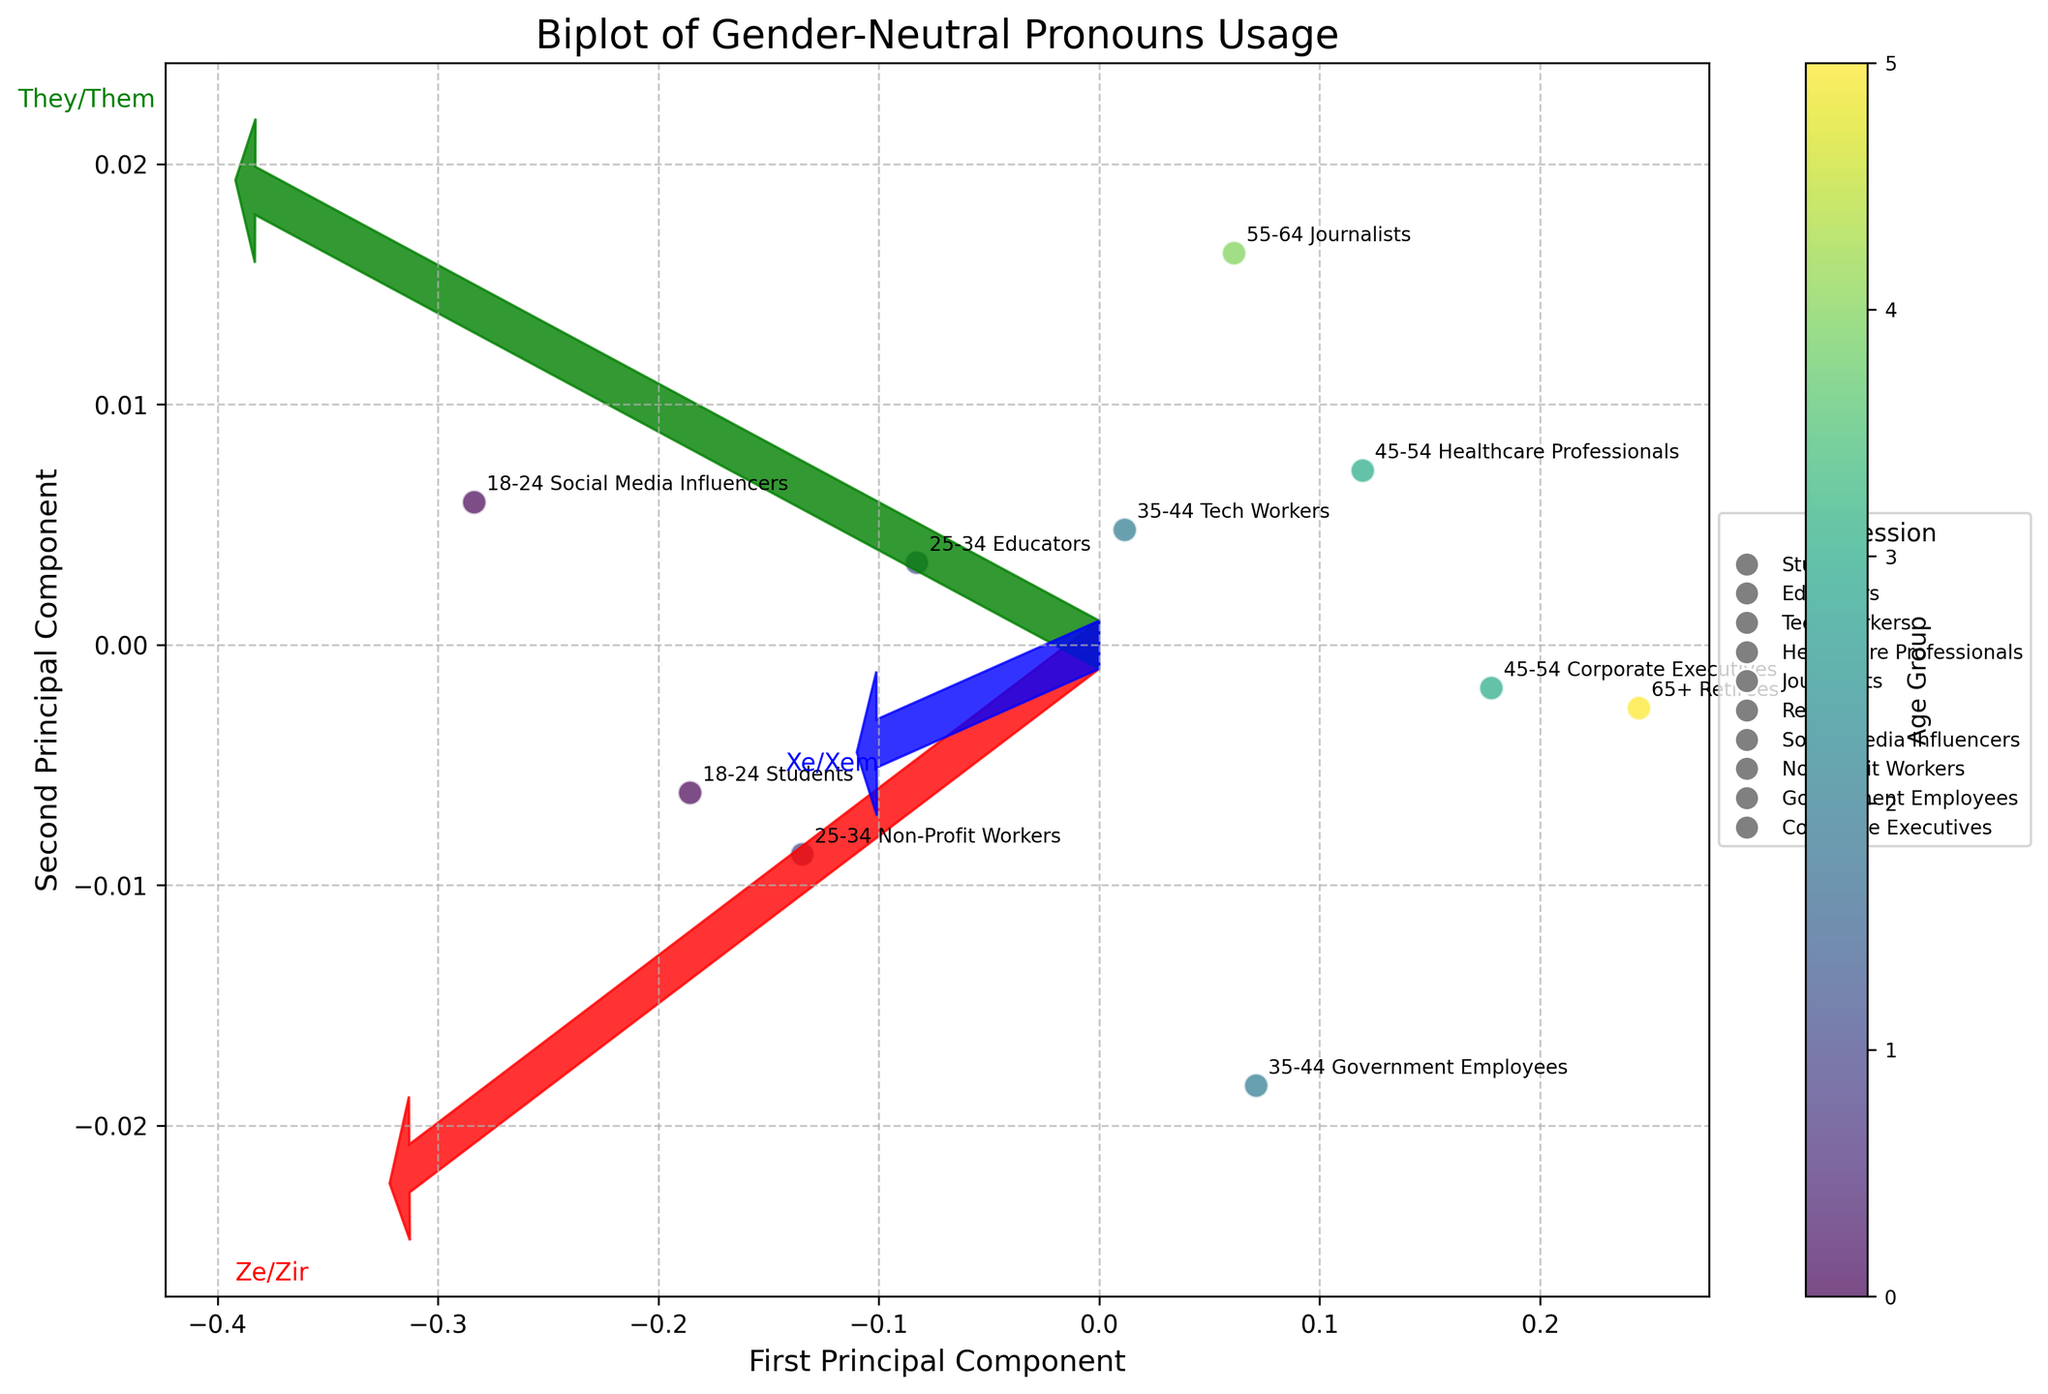What is the title of the figure? The title of the figure is typically displayed at the top of the plot. In this case, it is "Biplot of Gender-Neutral Pronouns Usage".
Answer: Biplot of Gender-Neutral Pronouns Usage Which age group predominantly uses "They/Them" pronouns the most? Look at the data points colored according to Age Groups and the length of the "They/Them" vector. The group closest to the vector will show higher usage. Social Media Influencers (18-24) seem closest to the arrow pointing to "They/Them".
Answer: 18-24 (Social Media Influencers) Which profession uses "Ze/Zir" pronouns more, Educators or Tech Workers? Look at the positions of "Educators" and "Tech Workers" in relation to the "Ze/Zir" vector. Educators (25-34) are closer to the vector than Tech Workers (35-44).
Answer: Educators Which age group has the lowest overall adoption of gender-neutral pronouns? Examine the positions of data points in relation to the origin (0, 0). The point farthest from all vectors represents minimal adoption. Retirees (65+) are farthest from the vectors.
Answer: 65+ (Retirees) How many different professions are represented in the figure? Check the legend for the list of professions represented. There are 9 different professions listed.
Answer: 9 Between Healthcare Professionals and Journalists, which group is closest to the "They/Them" usage vector? Locate the data points for Healthcare Professionals (45-54) and Journalists (55-64) and check their proximity to the "They/Them" vector. Healthcare Professionals are closer.
Answer: Healthcare Professionals What are the components on the axes of the biplot? The axes are labeled "First Principal Component" and "Second Principal Component".
Answer: First Principal Component, Second Principal Component 